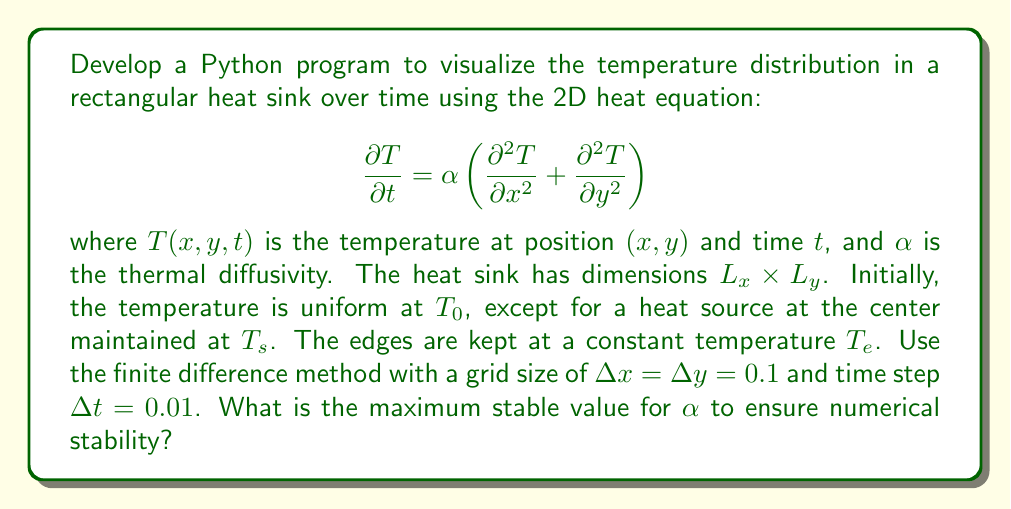Provide a solution to this math problem. To solve this problem, we need to consider the stability condition for the 2D heat equation using the finite difference method. The steps are as follows:

1. Recall the stability condition for the 2D heat equation:

   $$\alpha \frac{\Delta t}{(\Delta x)^2} + \alpha \frac{\Delta t}{(\Delta y)^2} \leq \frac{1}{2}$$

2. In our case, $\Delta x = \Delta y = 0.1$ and $\Delta t = 0.01$. Substituting these values:

   $$\alpha \frac{0.01}{(0.1)^2} + \alpha \frac{0.01}{(0.1)^2} \leq \frac{1}{2}$$

3. Simplify:

   $$\alpha \cdot 1 + \alpha \cdot 1 \leq \frac{1}{2}$$
   
   $$2\alpha \leq \frac{1}{2}$$

4. Solve for $\alpha$:

   $$\alpha \leq \frac{1}{4} = 0.25$$

Therefore, the maximum stable value for $\alpha$ is 0.25.
Answer: $\alpha_{\text{max}} = 0.25$ 